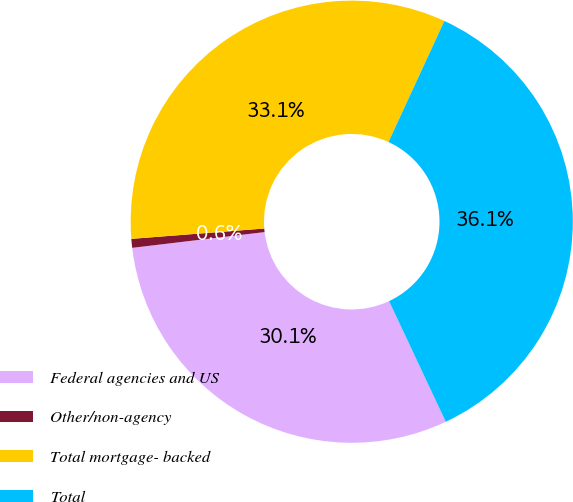Convert chart to OTSL. <chart><loc_0><loc_0><loc_500><loc_500><pie_chart><fcel>Federal agencies and US<fcel>Other/non-agency<fcel>Total mortgage- backed<fcel>Total<nl><fcel>30.11%<fcel>0.65%<fcel>33.12%<fcel>36.13%<nl></chart> 